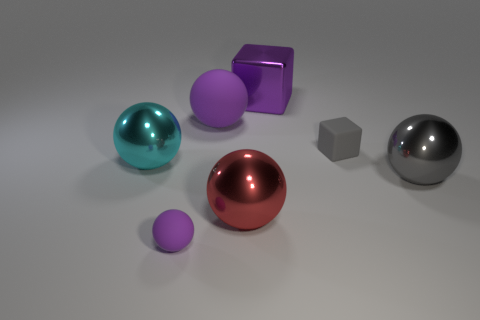What time of day could this scene represent based on the lighting? The scene doesn't provide direct clues about the time of day as it appears to be a controlled environment with even, artificial lighting which is commonly used in a studio setting. 